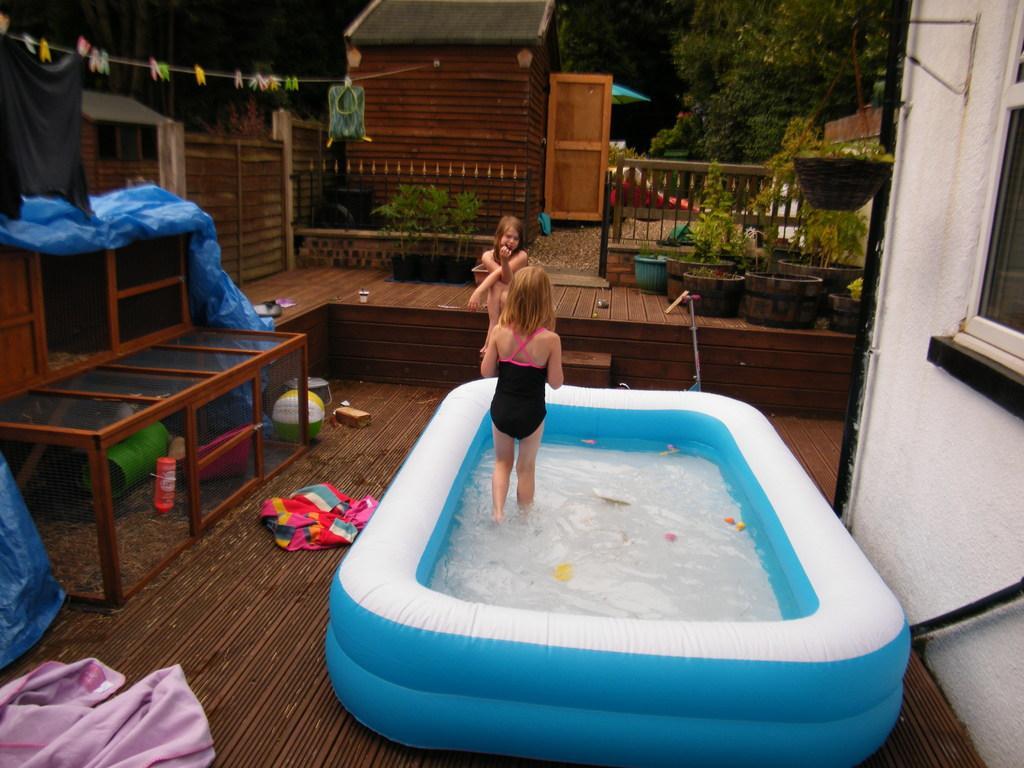Please provide a concise description of this image. In this picture we can see a tub full of water and a girl is standing in the water and other girl is sitting on the floor and left side of the tub here it is a glass cupboard and a cloth placed on the floor and a ball and here it is a bucket and the sheet. In the background we can see hut, tree, flower pot, plants, fence and a wire where clips are hanged to it. 